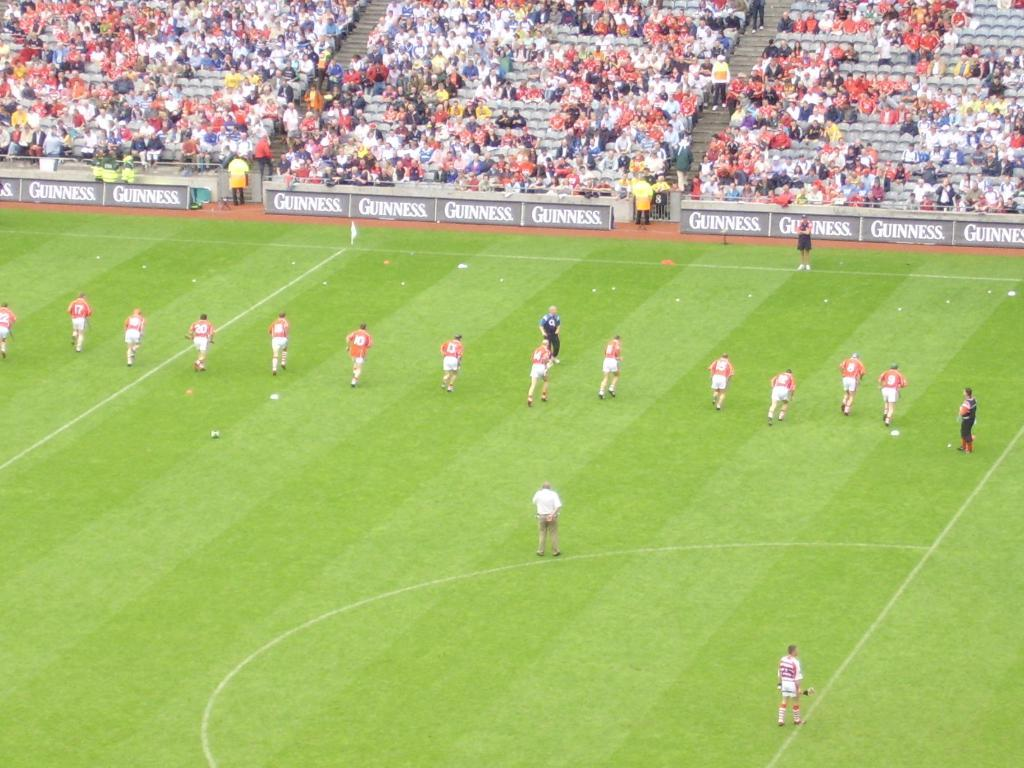<image>
Summarize the visual content of the image. Soccer players running toward banners that have Guiness in white letters. 